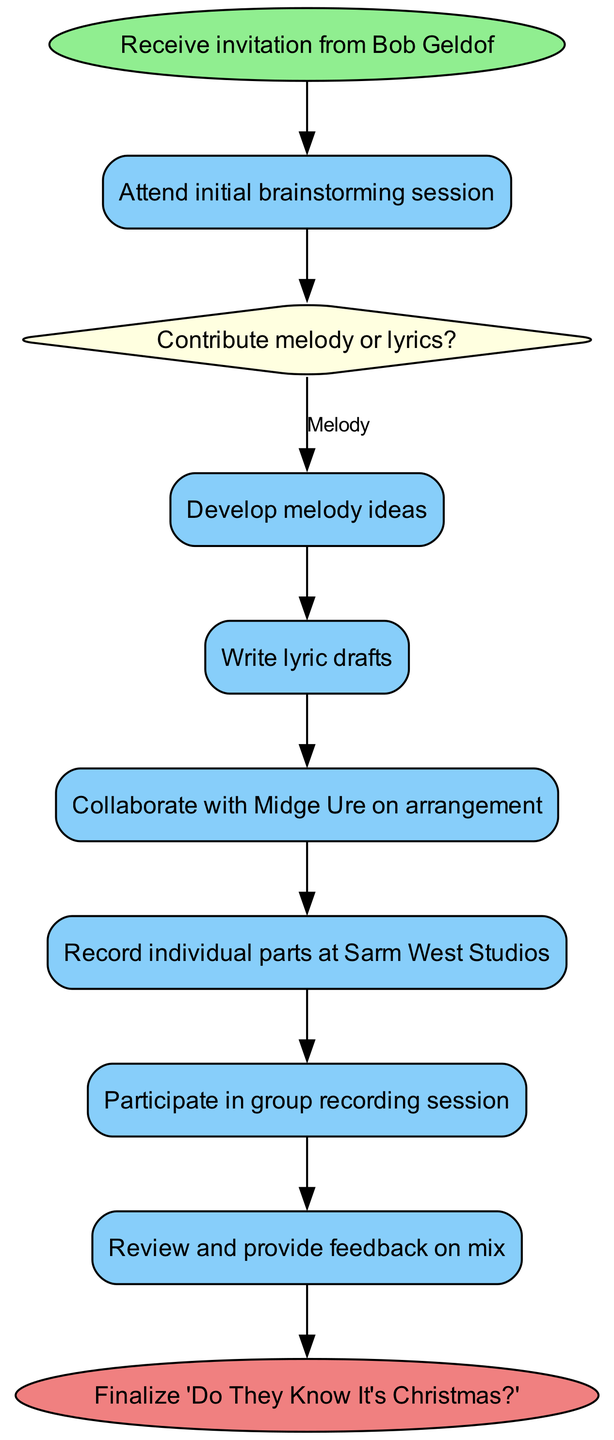What is the first step in the workflow? The first step in the workflow is indicated by the 'start' node, which shows the action of receiving an invitation from Bob Geldof.
Answer: Receive invitation from Bob Geldof How many main activities are in the diagram? By analyzing the diagram, we observe that there are five activities listed, which represent the key actions taken during the songwriting collaboration workflow.
Answer: 5 What is the final outcome of the collaboration? The last node in the diagram indicates the successful completion of the entire workflow, representing the final piece of work.
Answer: Finalize 'Do They Know It's Christmas?' What decision is made during the process? The diagram includes one decision-making node where contributors decide between two options regarding their contributions to the song.
Answer: Contribute melody or lyrics? Which activity involves collaboration with a specific person? The diagram specifies an activity where collaboration occurs with a specific individual, noted for their significant role in arrangement.
Answer: Collaborate with Midge Ure on arrangement What are the two output options after the decision node? The decision node branches into two different activities based on the contributor’s choice, which allows for dual paths in the workflow corresponding to either option.
Answer: Develop melody ideas, Write lyric drafts How do the activities connect after the decision? After the decision node, activities are connected based on contributions, showing that if melody is chosen, the next step is to develop melody ideas, while writing lyrics leads to lyric drafts.
Answer: Melody leads to developing ideas, Lyrics lead to writing drafts In what location are the individual parts recorded? The diagram indicates a specific studio where the recording of individual parts occurs, representing a crucial step in the production process.
Answer: Sarm West Studios 